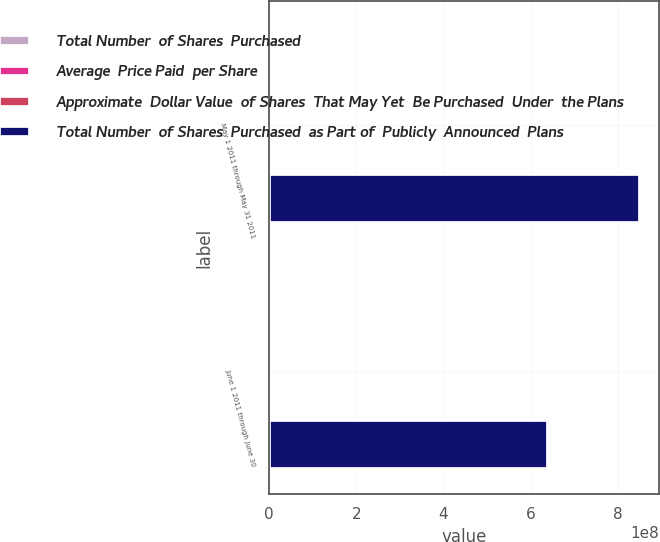<chart> <loc_0><loc_0><loc_500><loc_500><stacked_bar_chart><ecel><fcel>May 1 2011 through May 31 2011<fcel>June 1 2011 through June 30<nl><fcel>Total Number  of Shares  Purchased<fcel>727500<fcel>4.1571e+06<nl><fcel>Average  Price Paid  per Share<fcel>53.21<fcel>50.83<nl><fcel>Approximate  Dollar Value  of Shares  That May Yet  Be Purchased  Under  the Plans<fcel>727500<fcel>4.1571e+06<nl><fcel>Total Number  of Shares  Purchased  as Part of  Publicly  Announced  Plans<fcel>8.51342e+08<fcel>6.40053e+08<nl></chart> 